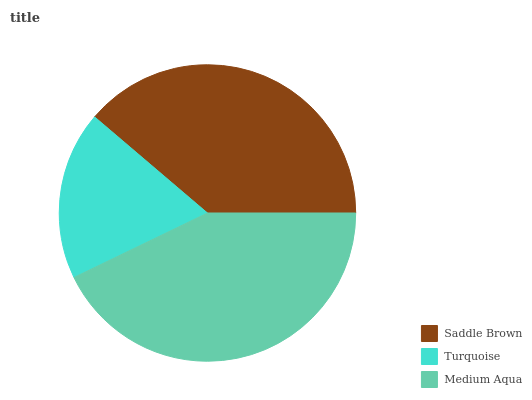Is Turquoise the minimum?
Answer yes or no. Yes. Is Medium Aqua the maximum?
Answer yes or no. Yes. Is Medium Aqua the minimum?
Answer yes or no. No. Is Turquoise the maximum?
Answer yes or no. No. Is Medium Aqua greater than Turquoise?
Answer yes or no. Yes. Is Turquoise less than Medium Aqua?
Answer yes or no. Yes. Is Turquoise greater than Medium Aqua?
Answer yes or no. No. Is Medium Aqua less than Turquoise?
Answer yes or no. No. Is Saddle Brown the high median?
Answer yes or no. Yes. Is Saddle Brown the low median?
Answer yes or no. Yes. Is Turquoise the high median?
Answer yes or no. No. Is Turquoise the low median?
Answer yes or no. No. 